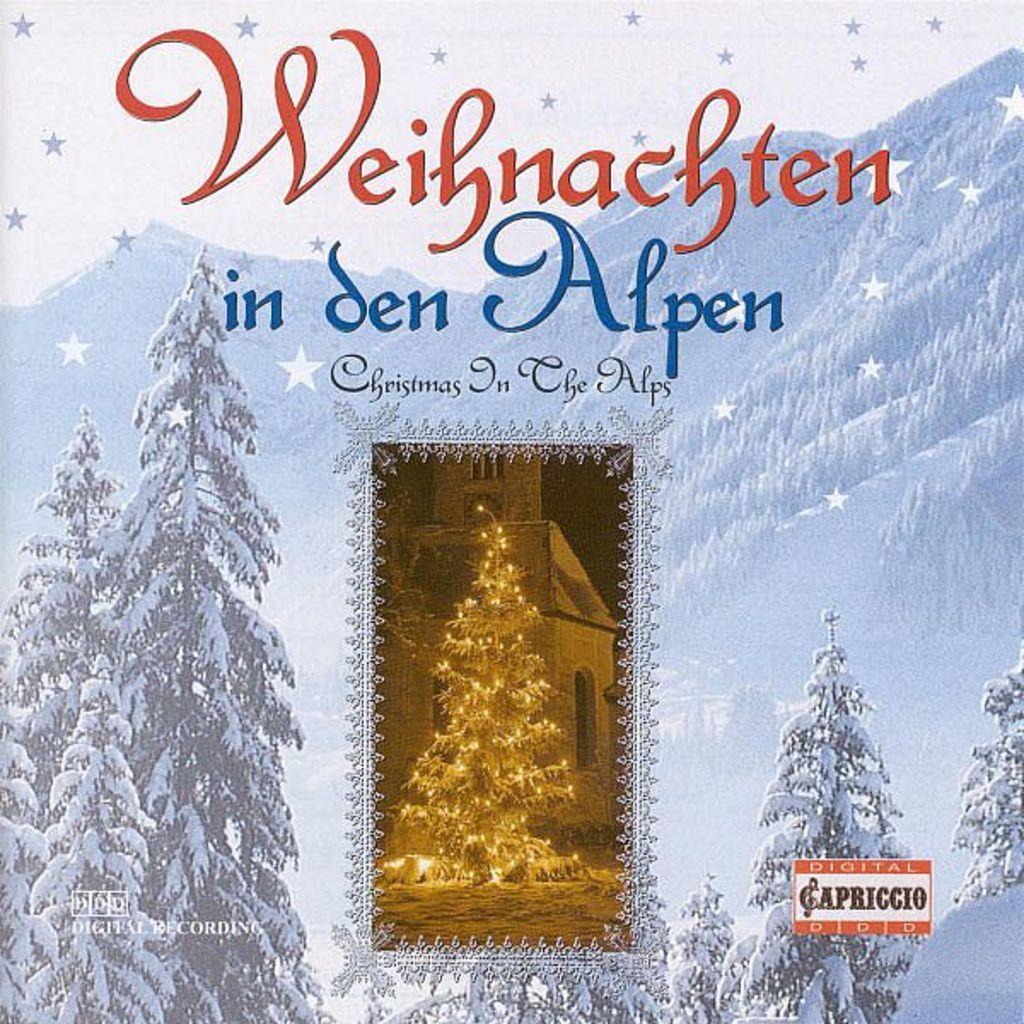In one or two sentences, can you explain what this image depicts? This is a poster and in this poster we can see trees, mountains, building with windows and a Christmas tree on the ground. 